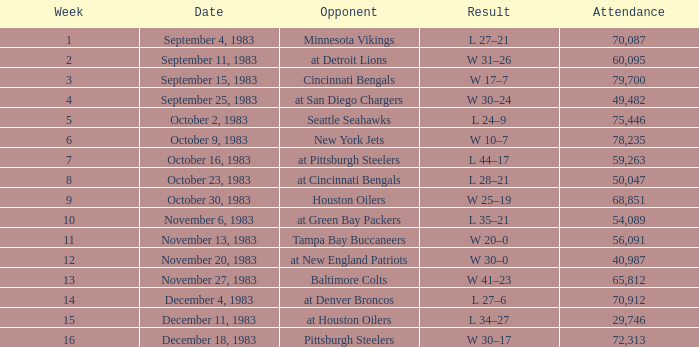Help me parse the entirety of this table. {'header': ['Week', 'Date', 'Opponent', 'Result', 'Attendance'], 'rows': [['1', 'September 4, 1983', 'Minnesota Vikings', 'L 27–21', '70,087'], ['2', 'September 11, 1983', 'at Detroit Lions', 'W 31–26', '60,095'], ['3', 'September 15, 1983', 'Cincinnati Bengals', 'W 17–7', '79,700'], ['4', 'September 25, 1983', 'at San Diego Chargers', 'W 30–24', '49,482'], ['5', 'October 2, 1983', 'Seattle Seahawks', 'L 24–9', '75,446'], ['6', 'October 9, 1983', 'New York Jets', 'W 10–7', '78,235'], ['7', 'October 16, 1983', 'at Pittsburgh Steelers', 'L 44–17', '59,263'], ['8', 'October 23, 1983', 'at Cincinnati Bengals', 'L 28–21', '50,047'], ['9', 'October 30, 1983', 'Houston Oilers', 'W 25–19', '68,851'], ['10', 'November 6, 1983', 'at Green Bay Packers', 'L 35–21', '54,089'], ['11', 'November 13, 1983', 'Tampa Bay Buccaneers', 'W 20–0', '56,091'], ['12', 'November 20, 1983', 'at New England Patriots', 'W 30–0', '40,987'], ['13', 'November 27, 1983', 'Baltimore Colts', 'W 41–23', '65,812'], ['14', 'December 4, 1983', 'at Denver Broncos', 'L 27–6', '70,912'], ['15', 'December 11, 1983', 'at Houston Oilers', 'L 34–27', '29,746'], ['16', 'December 18, 1983', 'Pittsburgh Steelers', 'W 30–17', '72,313']]} What is the average attendance after week 16? None. 